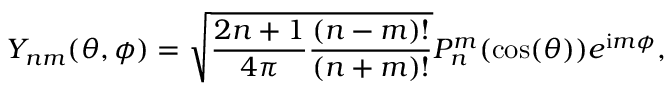Convert formula to latex. <formula><loc_0><loc_0><loc_500><loc_500>Y _ { n m } ( \theta , \phi ) = \sqrt { \frac { 2 n + 1 } { 4 \pi } \frac { ( n - m ) ! } { ( n + m ) ! } } P _ { n } ^ { m } ( \cos ( \theta ) ) e ^ { i m \phi } ,</formula> 